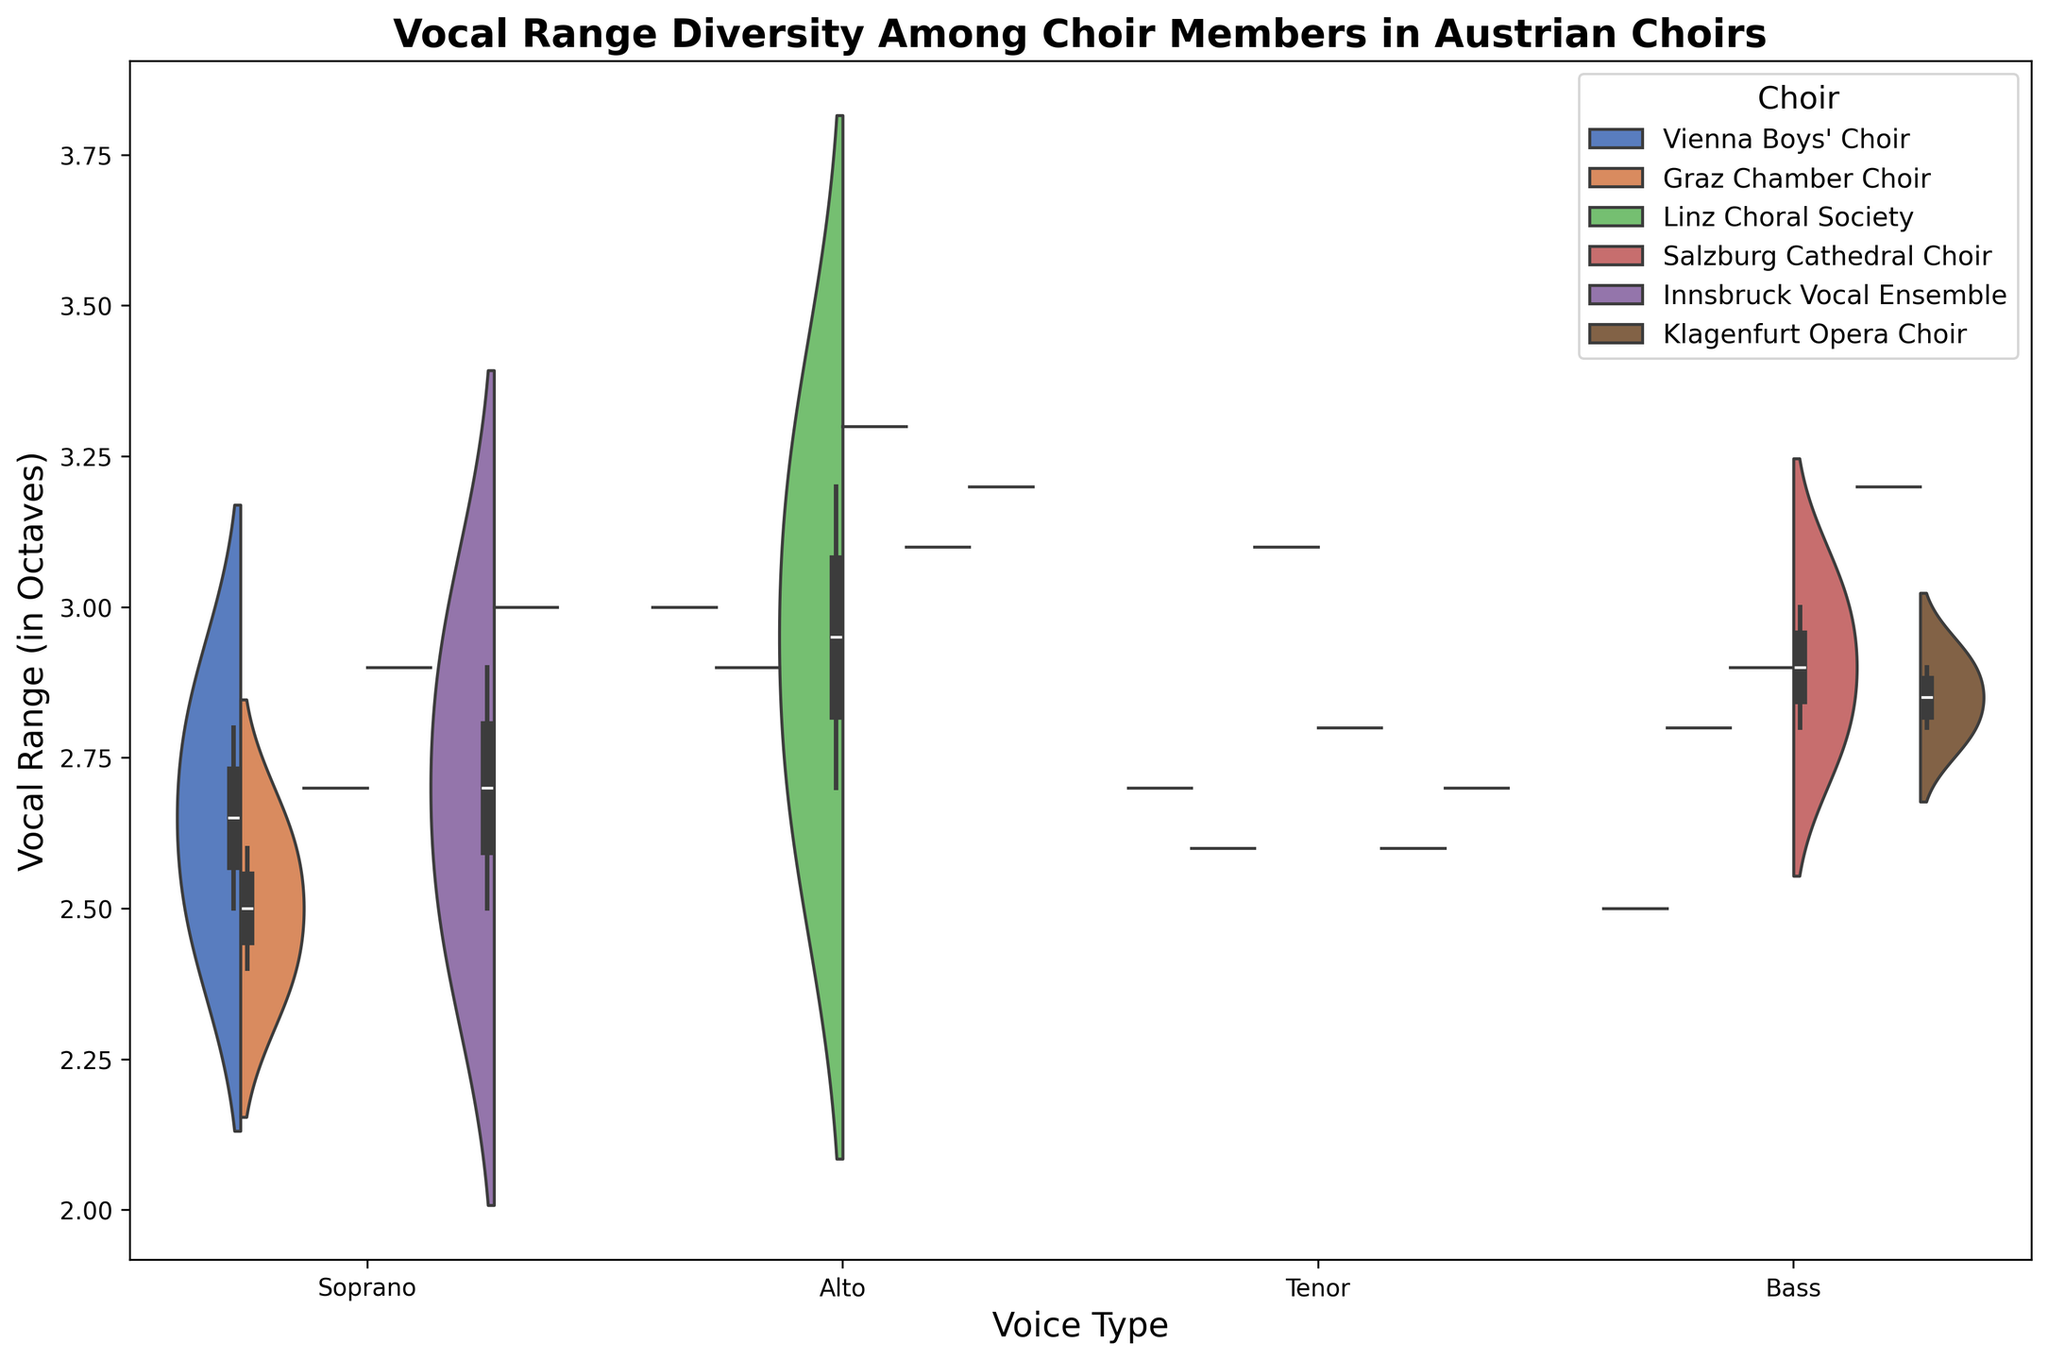Which voice type has the widest range in the Vienna Boys' Choir? In the violin plot, identify the range of each voice type within the Vienna Boys' Choir. Soprano ranges from 2.5 to 2.8, Alto is at 3.0, Tenor is at 2.7, and Bass is at 2.5. The widest range among them is the Alto at 3.0 octaves.
Answer: Alto Which choir shows the most variation in vocal ranges for the Bass voice? Examine the width and spread of the violin plots for the Bass voice across all choirs. The Innsbruck Vocal Ensemble's Bass voice plot stretches from 2.9 to 3.2 octaves, indicating significant variation. Other choirs have narrower spreads.
Answer: Innsbruck Vocal Ensemble What is the median vocal range for Sopranos in the Salzburg Cathedral Choir? Find the middle value in the vocal ranges of Sopranos for the Salzburg Cathedral Choir. The values are 2.9. Since there's only one data point, the median is 2.9.
Answer: 2.9 How does the median vocal range of Tenors in the Klagenfurt Opera Choir compare to that of the Linz Choral Society? For Tenors, the Klagenfurt Opera Choir has a range centered around 2.7, while the Linz Choral Society's median appears closer to 3.1. Therefore, the Linz Choral Society has a higher median vocal range for Tenors.
Answer: Linz Choral Society Are there any choirs where Altos consistently have a higher vocal range than Tenors? Compare the vocal range distribution for Altos and Tenors in each choir. In the Salzburg Cathedral Choir, the Alto range (centered around 3.3) is consistently higher than the Tenor range (centered around 2.8).
Answer: Salzburg Cathedral Choir What is the average range of Altos in the Graz Chamber Choir and how does it compare to that of the Linz Choral Society? The Graz Chamber Choir has Alto ranges at 2.9 and 3.0, averaging 2.95. The Linz Choral Society's Altos have ranges of 3.2 and 2.7, averaging 2.95. Both choirs have an average Alto range of 2.95 octaves.
Answer: 2.95, equal Which choir has the least variation in the vocal range of Sopranos? Look for the narrowest violin plot for Soprano voices. The Linz Choral Society's Soprano plot is tightly centered around 2.7, indicating minimal variation.
Answer: Linz Choral Society Among all choirs, which voice type shows the widest range of vocal diversity? Analyze the spread and width of the violin plots for each voice type across all choirs. The Alto voices show the widest range of vocal diversity, especially in the Salzburg Cathedral Choir (up to 3.3).
Answer: Alto In which choir does the Bass voice have the highest vocal range? Identify the peak of the Bass voice range for each choir. The highest peak observed is in the Innsbruck Vocal Ensemble with a Bass voice reaching up to 3.2 octaves.
Answer: Innsbruck Vocal Ensemble 